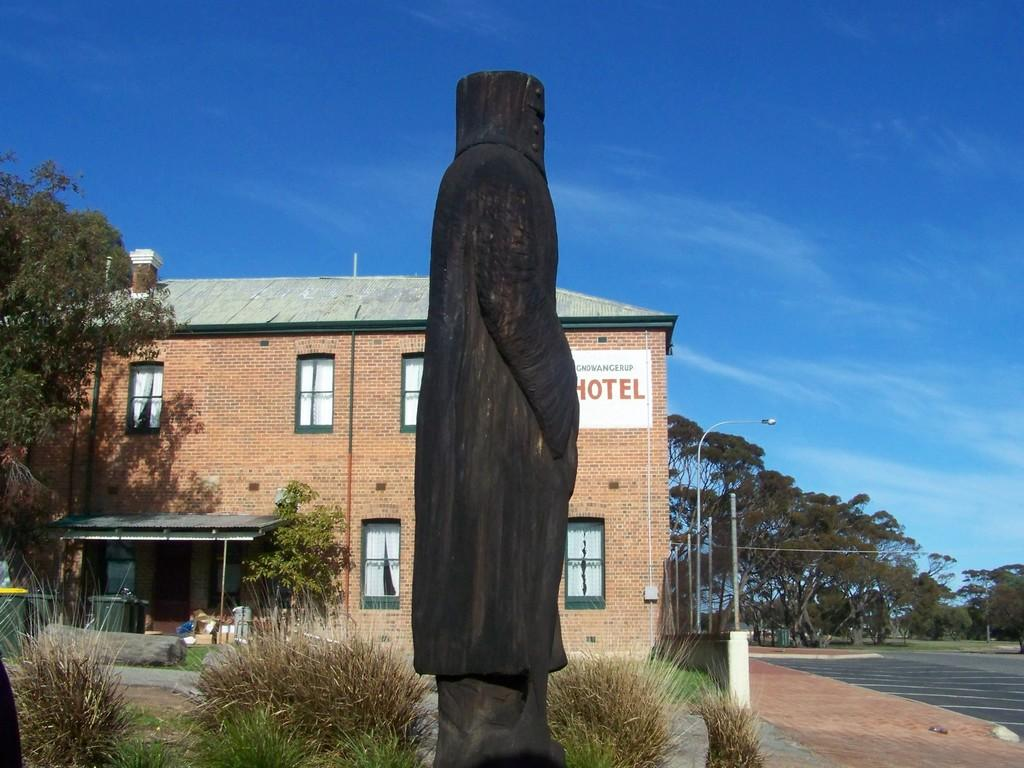What is the main subject of the image? There is a statue of a person in the image. What type of natural environment is visible in the image? There is grass, plants, trees, and the sky visible in the image. What type of structure is present in the image? There is a house in the image. What other objects can be seen in the image? There is a board and poles in the image. What type of apple is growing on the statue in the image? There is no apple growing on the statue in the image. What type of wool is being used to create a nest on the board in the image? There is no nest or wool present in the image. 